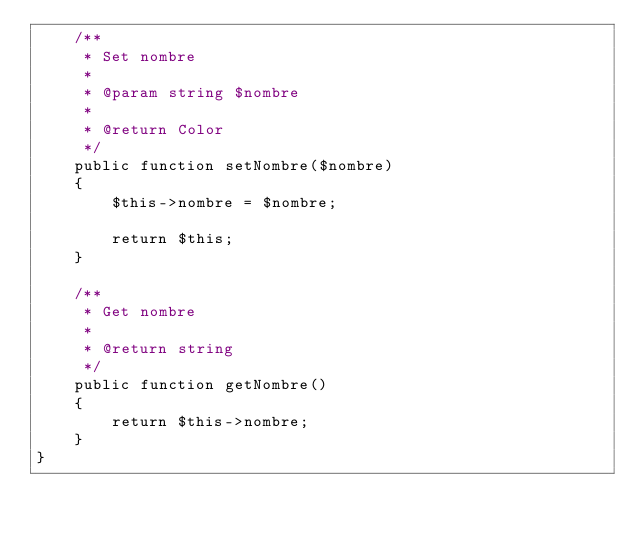<code> <loc_0><loc_0><loc_500><loc_500><_PHP_>    /**
     * Set nombre
     *
     * @param string $nombre
     *
     * @return Color
     */
    public function setNombre($nombre)
    {
        $this->nombre = $nombre;

        return $this;
    }

    /**
     * Get nombre
     *
     * @return string
     */
    public function getNombre()
    {
        return $this->nombre;
    }
}

</code> 